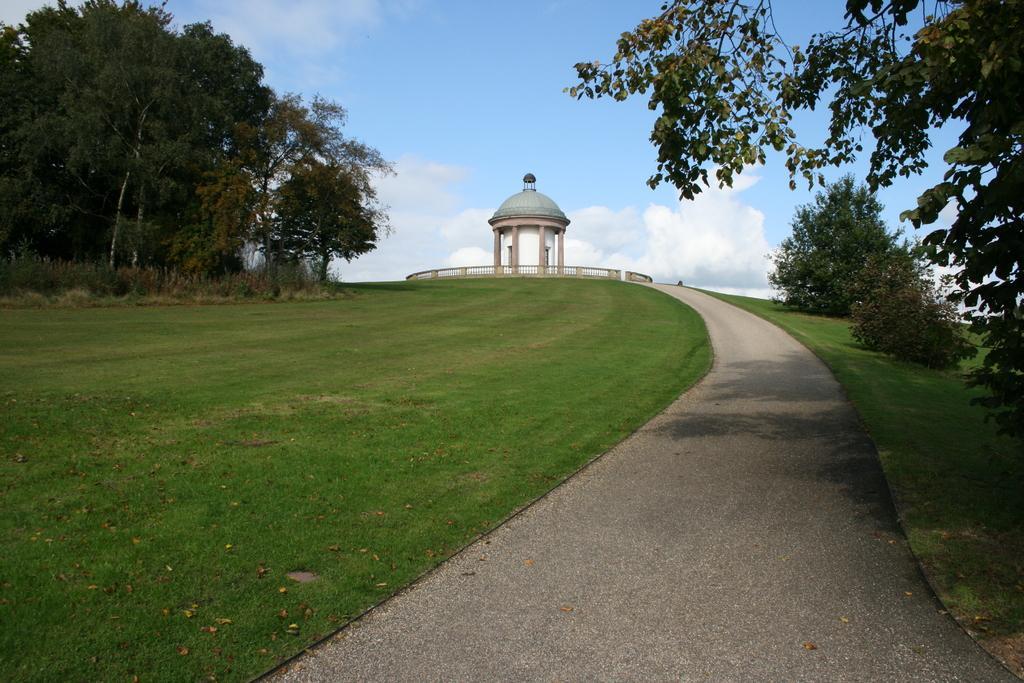How would you summarize this image in a sentence or two? In this image there is grass on the ground. On the right side there are plants. On the left side there are trees. In the background there is a railing, there is a tower and the sky is cloudy. 